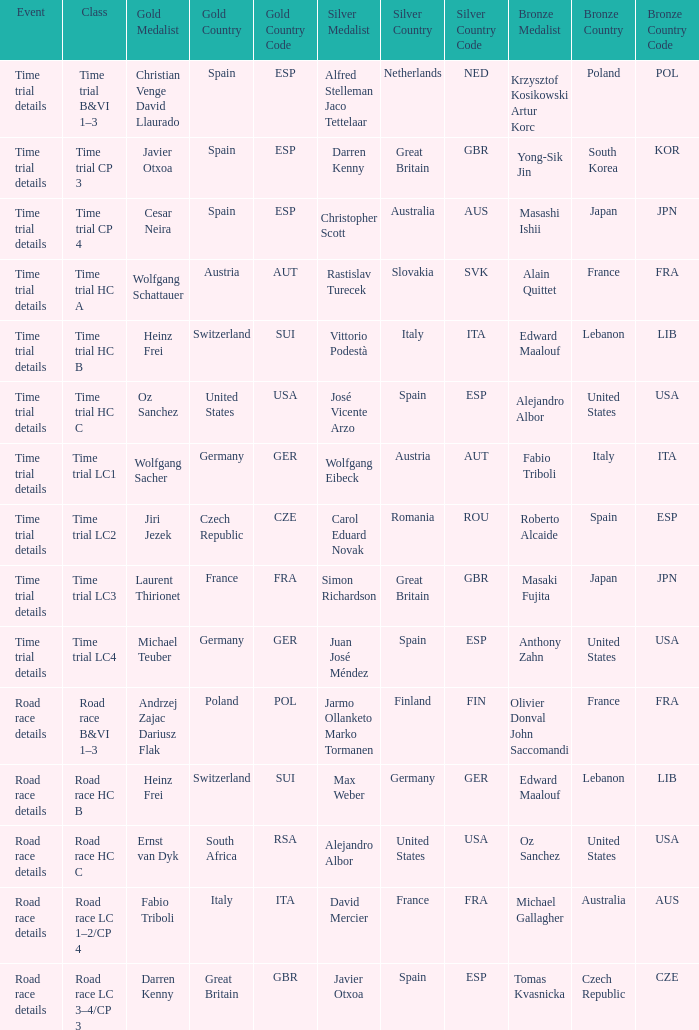I'm looking to parse the entire table for insights. Could you assist me with that? {'header': ['Event', 'Class', 'Gold Medalist', 'Gold Country', 'Gold Country Code', 'Silver Medalist', 'Silver Country', 'Silver Country Code', 'Bronze Medalist', 'Bronze Country', 'Bronze Country Code'], 'rows': [['Time trial details', 'Time trial B&VI 1–3', 'Christian Venge David Llaurado', 'Spain', 'ESP', 'Alfred Stelleman Jaco Tettelaar', 'Netherlands', 'NED', 'Krzysztof Kosikowski Artur Korc', 'Poland', 'POL'], ['Time trial details', 'Time trial CP 3', 'Javier Otxoa', 'Spain', 'ESP', 'Darren Kenny', 'Great Britain', 'GBR', 'Yong-Sik Jin', 'South Korea', 'KOR'], ['Time trial details', 'Time trial CP 4', 'Cesar Neira', 'Spain', 'ESP', 'Christopher Scott', 'Australia', 'AUS', 'Masashi Ishii', 'Japan', 'JPN'], ['Time trial details', 'Time trial HC A', 'Wolfgang Schattauer', 'Austria', 'AUT', 'Rastislav Turecek', 'Slovakia', 'SVK', 'Alain Quittet', 'France', 'FRA'], ['Time trial details', 'Time trial HC B', 'Heinz Frei', 'Switzerland', 'SUI', 'Vittorio Podestà', 'Italy', 'ITA', 'Edward Maalouf', 'Lebanon', 'LIB'], ['Time trial details', 'Time trial HC C', 'Oz Sanchez', 'United States', 'USA', 'José Vicente Arzo', 'Spain', 'ESP', 'Alejandro Albor', 'United States', 'USA'], ['Time trial details', 'Time trial LC1', 'Wolfgang Sacher', 'Germany', 'GER', 'Wolfgang Eibeck', 'Austria', 'AUT', 'Fabio Triboli', 'Italy', 'ITA'], ['Time trial details', 'Time trial LC2', 'Jiri Jezek', 'Czech Republic', 'CZE', 'Carol Eduard Novak', 'Romania', 'ROU', 'Roberto Alcaide', 'Spain', 'ESP'], ['Time trial details', 'Time trial LC3', 'Laurent Thirionet', 'France', 'FRA', 'Simon Richardson', 'Great Britain', 'GBR', 'Masaki Fujita', 'Japan', 'JPN'], ['Time trial details', 'Time trial LC4', 'Michael Teuber', 'Germany', 'GER', 'Juan José Méndez', 'Spain', 'ESP', 'Anthony Zahn', 'United States', 'USA'], ['Road race details', 'Road race B&VI 1–3', 'Andrzej Zajac Dariusz Flak', 'Poland', 'POL', 'Jarmo Ollanketo Marko Tormanen', 'Finland', 'FIN', 'Olivier Donval John Saccomandi', 'France', 'FRA'], ['Road race details', 'Road race HC B', 'Heinz Frei', 'Switzerland', 'SUI', 'Max Weber', 'Germany', 'GER', 'Edward Maalouf', 'Lebanon', 'LIB'], ['Road race details', 'Road race HC C', 'Ernst van Dyk', 'South Africa', 'RSA', 'Alejandro Albor', 'United States', 'USA', 'Oz Sanchez', 'United States', 'USA'], ['Road race details', 'Road race LC 1–2/CP 4', 'Fabio Triboli', 'Italy', 'ITA', 'David Mercier', 'France', 'FRA', 'Michael Gallagher', 'Australia', 'AUS'], ['Road race details', 'Road race LC 3–4/CP 3', 'Darren Kenny', 'Great Britain', 'GBR', 'Javier Otxoa', 'Spain', 'ESP', 'Tomas Kvasnicka', 'Czech Republic', 'CZE']]} Who won the gold medal when wolfgang eibeck from austria (aut) secured the silver? Wolfgang Sacher Germany (GER). 